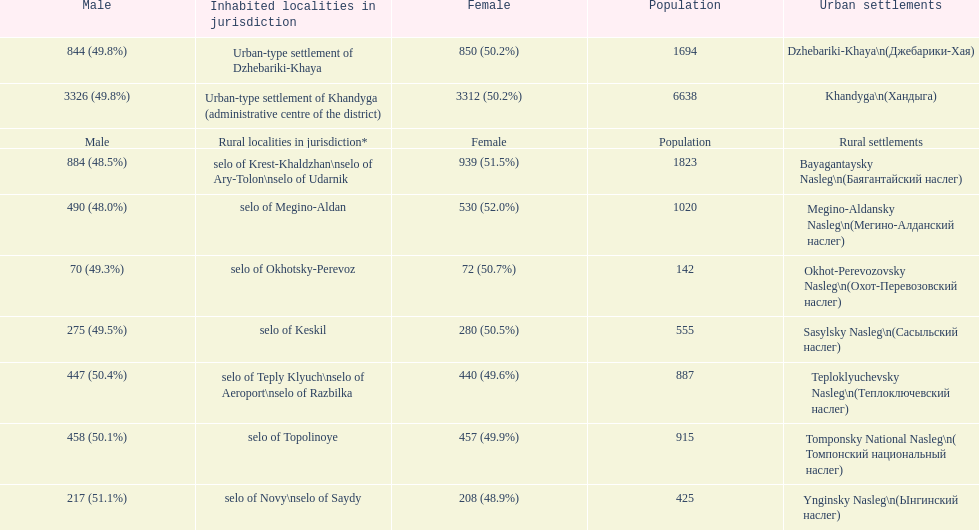Which rural settlement has the most males in their population? Bayagantaysky Nasleg (Áàÿãàíòàéñêèé íàñëåã). 